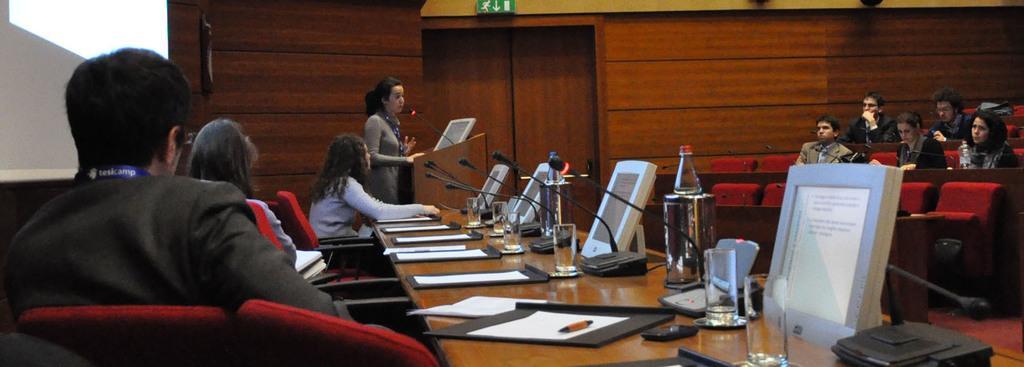In one or two sentences, can you explain what this image depicts? In this image I can see group of people sitting and I can also see few screens, microphones, bottles, papers, glasses on the table. In the background I can see the person standing in front of the podium and I can also see the projection screen and I can see the wooden wall and the wall is in brown color. 